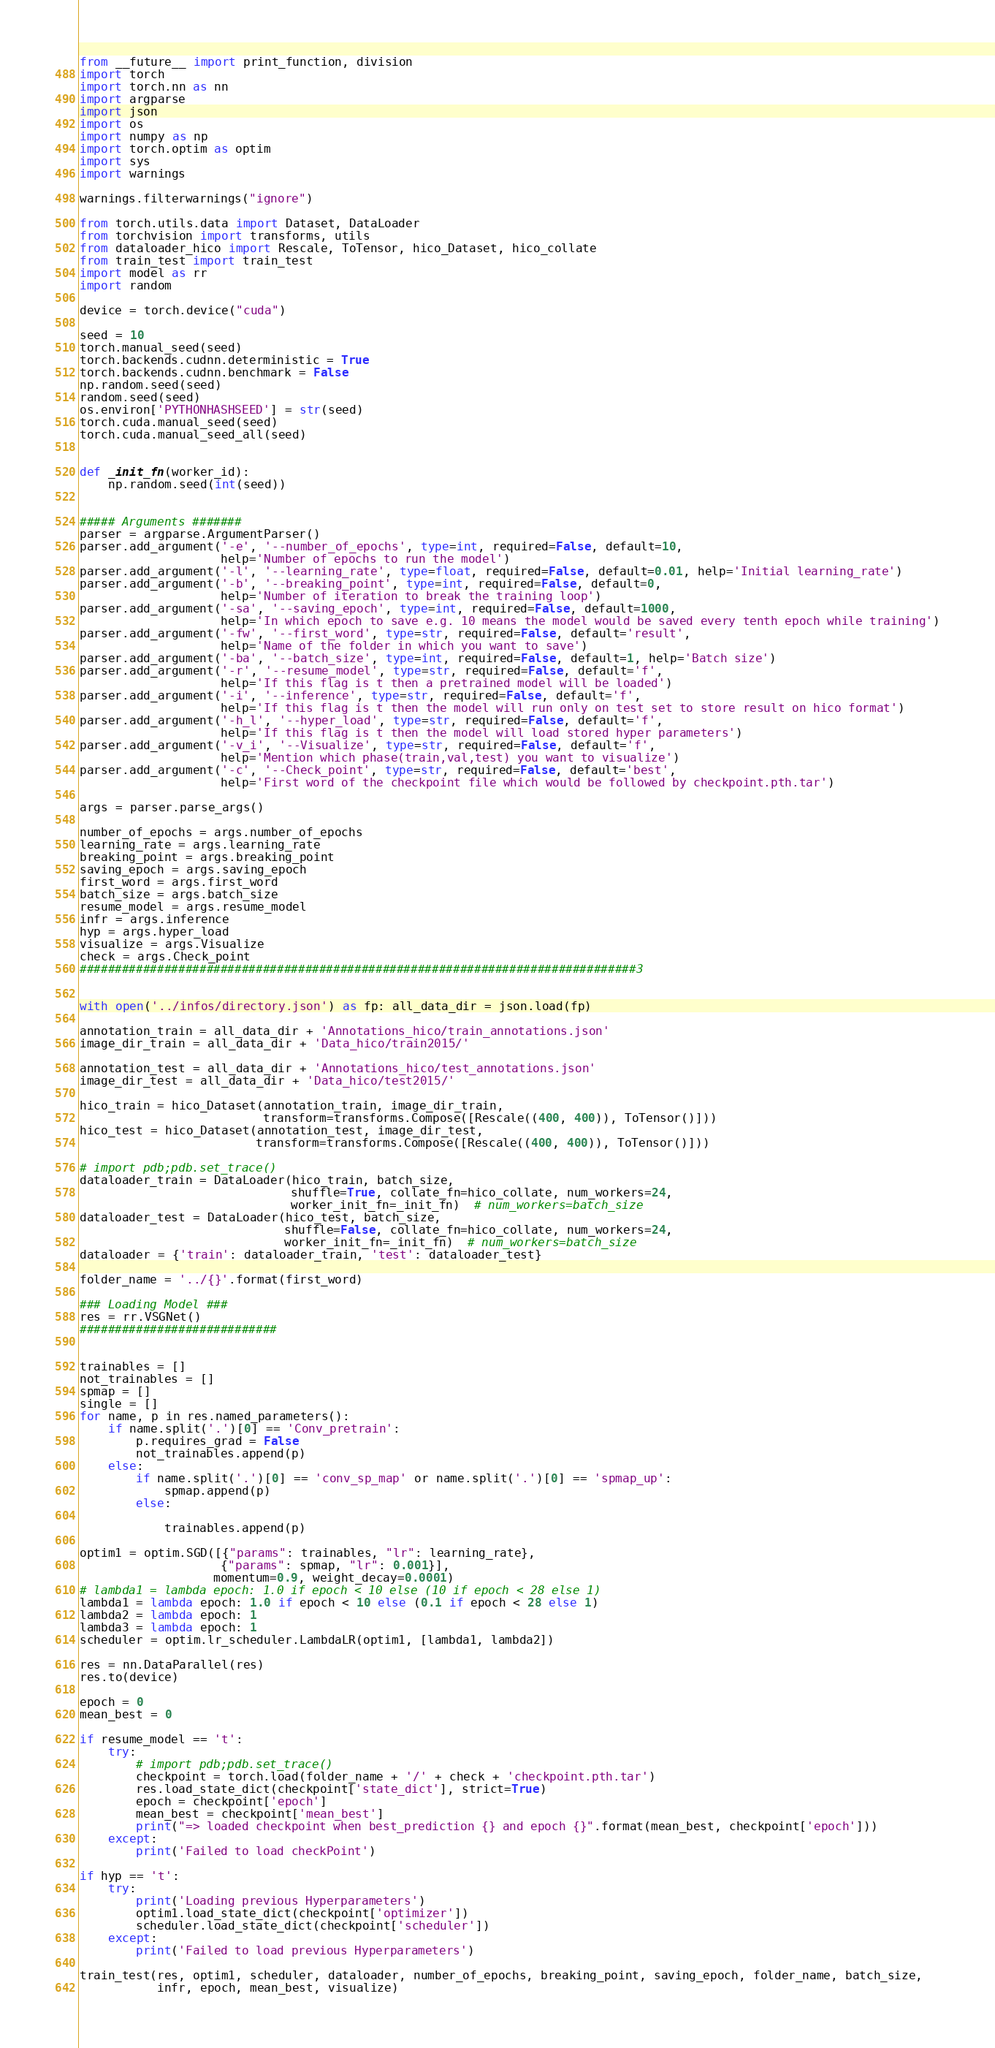<code> <loc_0><loc_0><loc_500><loc_500><_Python_>from __future__ import print_function, division
import torch
import torch.nn as nn
import argparse
import json
import os
import numpy as np
import torch.optim as optim
import sys
import warnings

warnings.filterwarnings("ignore")

from torch.utils.data import Dataset, DataLoader
from torchvision import transforms, utils
from dataloader_hico import Rescale, ToTensor, hico_Dataset, hico_collate
from train_test import train_test
import model as rr
import random

device = torch.device("cuda")

seed = 10
torch.manual_seed(seed)
torch.backends.cudnn.deterministic = True
torch.backends.cudnn.benchmark = False
np.random.seed(seed)
random.seed(seed)
os.environ['PYTHONHASHSEED'] = str(seed)
torch.cuda.manual_seed(seed)
torch.cuda.manual_seed_all(seed)


def _init_fn(worker_id):
    np.random.seed(int(seed))


##### Arguments #######
parser = argparse.ArgumentParser()
parser.add_argument('-e', '--number_of_epochs', type=int, required=False, default=10,
                    help='Number of epochs to run the model')
parser.add_argument('-l', '--learning_rate', type=float, required=False, default=0.01, help='Initial learning_rate')
parser.add_argument('-b', '--breaking_point', type=int, required=False, default=0,
                    help='Number of iteration to break the training loop')
parser.add_argument('-sa', '--saving_epoch', type=int, required=False, default=1000,
                    help='In which epoch to save e.g. 10 means the model would be saved every tenth epoch while training')
parser.add_argument('-fw', '--first_word', type=str, required=False, default='result',
                    help='Name of the folder in which you want to save')
parser.add_argument('-ba', '--batch_size', type=int, required=False, default=1, help='Batch size')
parser.add_argument('-r', '--resume_model', type=str, required=False, default='f',
                    help='If this flag is t then a pretrained model will be loaded')
parser.add_argument('-i', '--inference', type=str, required=False, default='f',
                    help='If this flag is t then the model will run only on test set to store result on hico format')
parser.add_argument('-h_l', '--hyper_load', type=str, required=False, default='f',
                    help='If this flag is t then the model will load stored hyper parameters')
parser.add_argument('-v_i', '--Visualize', type=str, required=False, default='f',
                    help='Mention which phase(train,val,test) you want to visualize')
parser.add_argument('-c', '--Check_point', type=str, required=False, default='best',
                    help='First word of the checkpoint file which would be followed by checkpoint.pth.tar')

args = parser.parse_args()

number_of_epochs = args.number_of_epochs
learning_rate = args.learning_rate
breaking_point = args.breaking_point
saving_epoch = args.saving_epoch
first_word = args.first_word
batch_size = args.batch_size
resume_model = args.resume_model
infr = args.inference
hyp = args.hyper_load
visualize = args.Visualize
check = args.Check_point
###############################################################################3


with open('../infos/directory.json') as fp: all_data_dir = json.load(fp)

annotation_train = all_data_dir + 'Annotations_hico/train_annotations.json'
image_dir_train = all_data_dir + 'Data_hico/train2015/'

annotation_test = all_data_dir + 'Annotations_hico/test_annotations.json'
image_dir_test = all_data_dir + 'Data_hico/test2015/'

hico_train = hico_Dataset(annotation_train, image_dir_train,
                          transform=transforms.Compose([Rescale((400, 400)), ToTensor()]))
hico_test = hico_Dataset(annotation_test, image_dir_test,
                         transform=transforms.Compose([Rescale((400, 400)), ToTensor()]))

# import pdb;pdb.set_trace()
dataloader_train = DataLoader(hico_train, batch_size,
                              shuffle=True, collate_fn=hico_collate, num_workers=24,
                              worker_init_fn=_init_fn)  # num_workers=batch_size
dataloader_test = DataLoader(hico_test, batch_size,
                             shuffle=False, collate_fn=hico_collate, num_workers=24,
                             worker_init_fn=_init_fn)  # num_workers=batch_size
dataloader = {'train': dataloader_train, 'test': dataloader_test}

folder_name = '../{}'.format(first_word)

### Loading Model ###
res = rr.VSGNet()
############################


trainables = []
not_trainables = []
spmap = []
single = []
for name, p in res.named_parameters():
    if name.split('.')[0] == 'Conv_pretrain':
        p.requires_grad = False
        not_trainables.append(p)
    else:
        if name.split('.')[0] == 'conv_sp_map' or name.split('.')[0] == 'spmap_up':
            spmap.append(p)
        else:

            trainables.append(p)

optim1 = optim.SGD([{"params": trainables, "lr": learning_rate},
                    {"params": spmap, "lr": 0.001}],
                   momentum=0.9, weight_decay=0.0001)
# lambda1 = lambda epoch: 1.0 if epoch < 10 else (10 if epoch < 28 else 1)
lambda1 = lambda epoch: 1.0 if epoch < 10 else (0.1 if epoch < 28 else 1)
lambda2 = lambda epoch: 1
lambda3 = lambda epoch: 1
scheduler = optim.lr_scheduler.LambdaLR(optim1, [lambda1, lambda2])

res = nn.DataParallel(res)
res.to(device)

epoch = 0
mean_best = 0

if resume_model == 't':
    try:
        # import pdb;pdb.set_trace()
        checkpoint = torch.load(folder_name + '/' + check + 'checkpoint.pth.tar')
        res.load_state_dict(checkpoint['state_dict'], strict=True)
        epoch = checkpoint['epoch']
        mean_best = checkpoint['mean_best']
        print("=> loaded checkpoint when best_prediction {} and epoch {}".format(mean_best, checkpoint['epoch']))
    except:
        print('Failed to load checkPoint')

if hyp == 't':
    try:
        print('Loading previous Hyperparameters')
        optim1.load_state_dict(checkpoint['optimizer'])
        scheduler.load_state_dict(checkpoint['scheduler'])
    except:
        print('Failed to load previous Hyperparameters')

train_test(res, optim1, scheduler, dataloader, number_of_epochs, breaking_point, saving_epoch, folder_name, batch_size,
           infr, epoch, mean_best, visualize)
</code> 